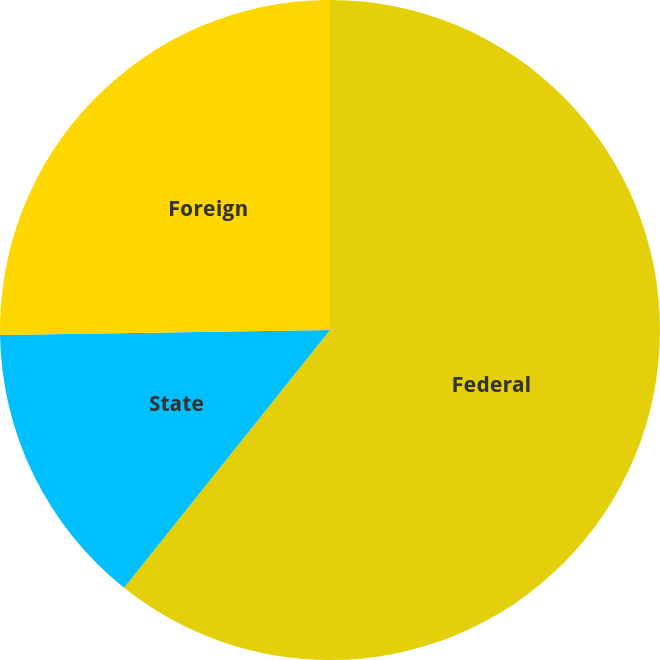<chart> <loc_0><loc_0><loc_500><loc_500><pie_chart><fcel>Federal<fcel>State<fcel>Foreign<nl><fcel>60.72%<fcel>14.03%<fcel>25.24%<nl></chart> 